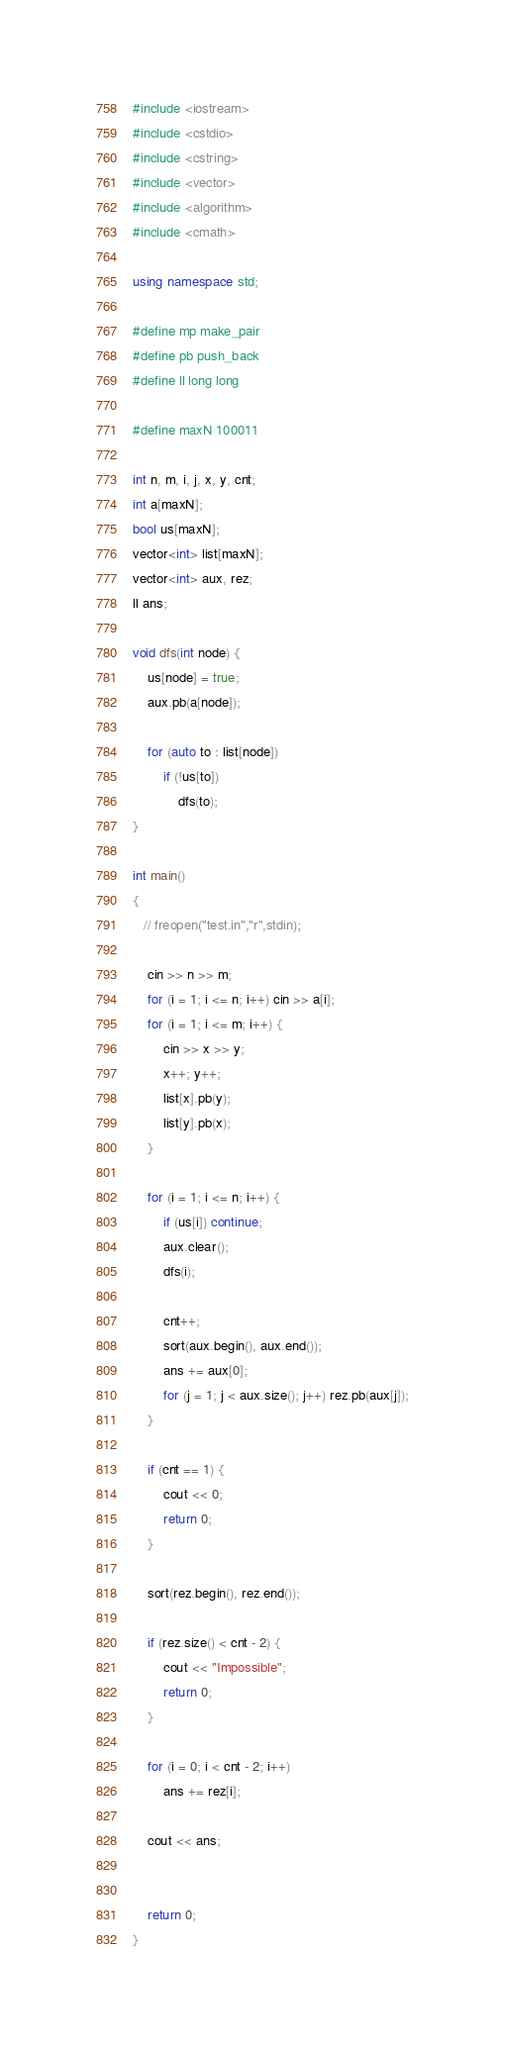<code> <loc_0><loc_0><loc_500><loc_500><_C++_>#include <iostream>
#include <cstdio>
#include <cstring>
#include <vector>
#include <algorithm>
#include <cmath>

using namespace std;

#define mp make_pair
#define pb push_back
#define ll long long

#define maxN 100011

int n, m, i, j, x, y, cnt;
int a[maxN];
bool us[maxN];
vector<int> list[maxN];
vector<int> aux, rez;
ll ans;

void dfs(int node) {
    us[node] = true;
    aux.pb(a[node]);

    for (auto to : list[node])
        if (!us[to])
            dfs(to);
}

int main()
{
   // freopen("test.in","r",stdin);

    cin >> n >> m;
    for (i = 1; i <= n; i++) cin >> a[i];
    for (i = 1; i <= m; i++) {
        cin >> x >> y;
        x++; y++;
        list[x].pb(y);
        list[y].pb(x);
    }

    for (i = 1; i <= n; i++) {
        if (us[i]) continue;
        aux.clear();
        dfs(i);

        cnt++;
        sort(aux.begin(), aux.end());
        ans += aux[0];
        for (j = 1; j < aux.size(); j++) rez.pb(aux[j]);
    }

    if (cnt == 1) {
        cout << 0;
        return 0;
    }

    sort(rez.begin(), rez.end());

    if (rez.size() < cnt - 2) {
        cout << "Impossible";
        return 0;
    }

    for (i = 0; i < cnt - 2; i++)
        ans += rez[i];

    cout << ans;


    return 0;
}
</code> 